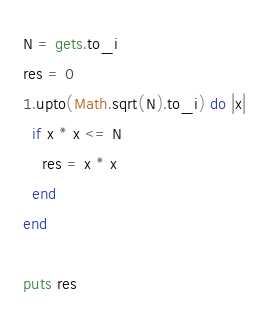Convert code to text. <code><loc_0><loc_0><loc_500><loc_500><_Ruby_>N = gets.to_i
res = 0
1.upto(Math.sqrt(N).to_i) do |x|
  if x * x <= N
    res = x * x
  end
end

puts res
</code> 